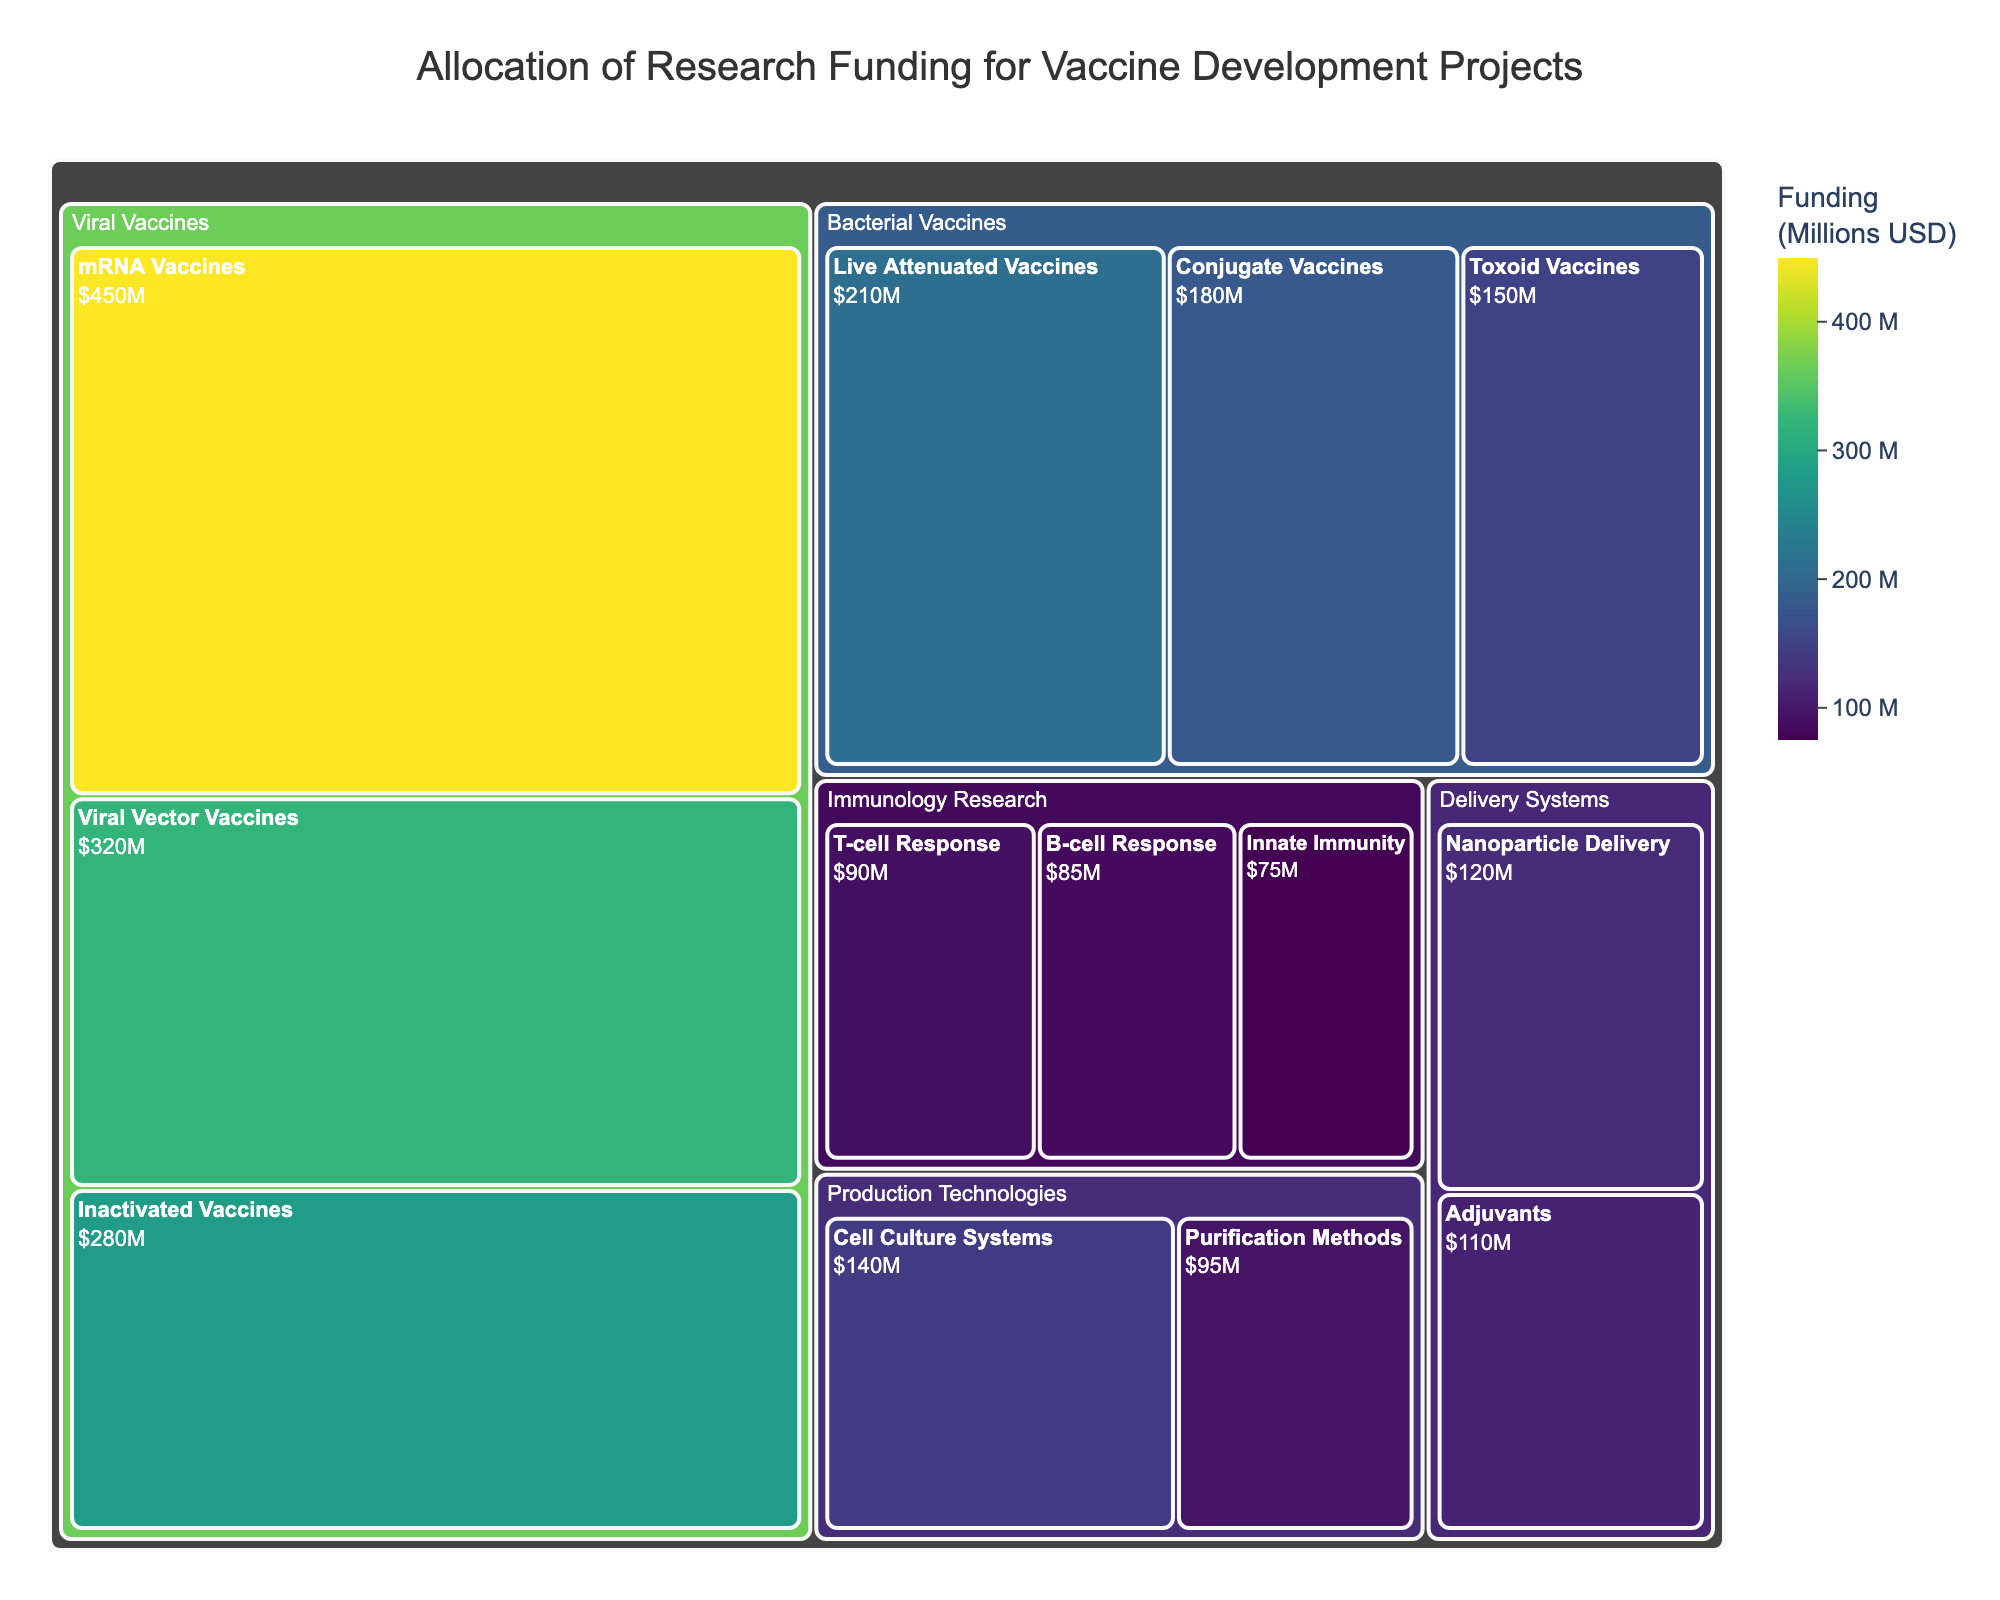What is the title of the treemap? The title of the figure is displayed prominently at the top of the treemap and is usually in a larger font size.
Answer: Allocation of Research Funding for Vaccine Development Projects Which category received the highest total funding? To determine the category with the highest total funding, you need to sum the funding for each subcategory within each main category. Compare these sums to find the category with the highest total.
Answer: Viral Vaccines How much funding was allocated to mRNA Vaccines? Locate the subcategory 'mRNA Vaccines' within the 'Viral Vaccines' category. The funding amount is directly displayed on the corresponding section of the treemap.
Answer: 450 million USD What is the combined funding for T-cell Response and B-cell Response research? Find the funding amounts for both 'T-cell Response' and 'B-cell Response' under the 'Immunology Research' category and add them together: 90 million + 85 million.
Answer: 175 million USD Which category has the least funding for its subcategories, and what is that amount? Compare the funding amounts of each subcategory within all categories. The 'Innate Immunity' subcategory under 'Immunology Research' has the smallest amount.
Answer: Innate Immunity, 75 million USD How does the funding for Viral Vector Vaccines compare to that for Live Attenuated Vaccines? Identify the funding for 'Viral Vector Vaccines' under 'Viral Vaccines' and 'Live Attenuated Vaccines' under the 'Bacterial Vaccines' category. Compare these values.
Answer: Viral Vector Vaccines received 320 million USD, and Live Attenuated Vaccines received 210 million USD, so Viral Vector Vaccines received more funding What is the total funding allocated to the Delivery Systems category? Add the funding amounts for both 'Nanoparticle Delivery' and 'Adjuvants' subcategories in the 'Delivery Systems' category: 120 million + 110 million.
Answer: 230 million USD Which subcategory has the second-highest funding? Compare the funding among all subcategories and identify the one with the second-highest funding.
Answer: Viral Vector Vaccines How much more funding does Conjugate Vaccines receive compared to Toxoid Vaccines? Subtract the funding amount for 'Toxoid Vaccines' under 'Bacterial Vaccines' from that for 'Conjugate Vaccines': 180 million - 150 million.
Answer: 30 million USD What is the average funding for the subcategories under the Immunology Research category? Add the funding amounts for 'T-cell Response', 'B-cell Response', and 'Innate Immunity' and divide by the number of subcategories: (90 million + 85 million + 75 million) / 3.
Answer: 83.33 million USD 